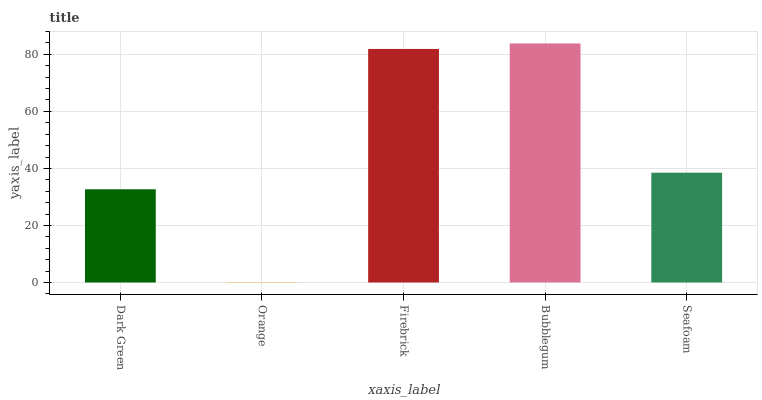Is Orange the minimum?
Answer yes or no. Yes. Is Bubblegum the maximum?
Answer yes or no. Yes. Is Firebrick the minimum?
Answer yes or no. No. Is Firebrick the maximum?
Answer yes or no. No. Is Firebrick greater than Orange?
Answer yes or no. Yes. Is Orange less than Firebrick?
Answer yes or no. Yes. Is Orange greater than Firebrick?
Answer yes or no. No. Is Firebrick less than Orange?
Answer yes or no. No. Is Seafoam the high median?
Answer yes or no. Yes. Is Seafoam the low median?
Answer yes or no. Yes. Is Orange the high median?
Answer yes or no. No. Is Bubblegum the low median?
Answer yes or no. No. 